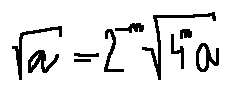Convert formula to latex. <formula><loc_0><loc_0><loc_500><loc_500>\sqrt { a } = 2 ^ { - n } \sqrt { 4 ^ { n } a }</formula> 